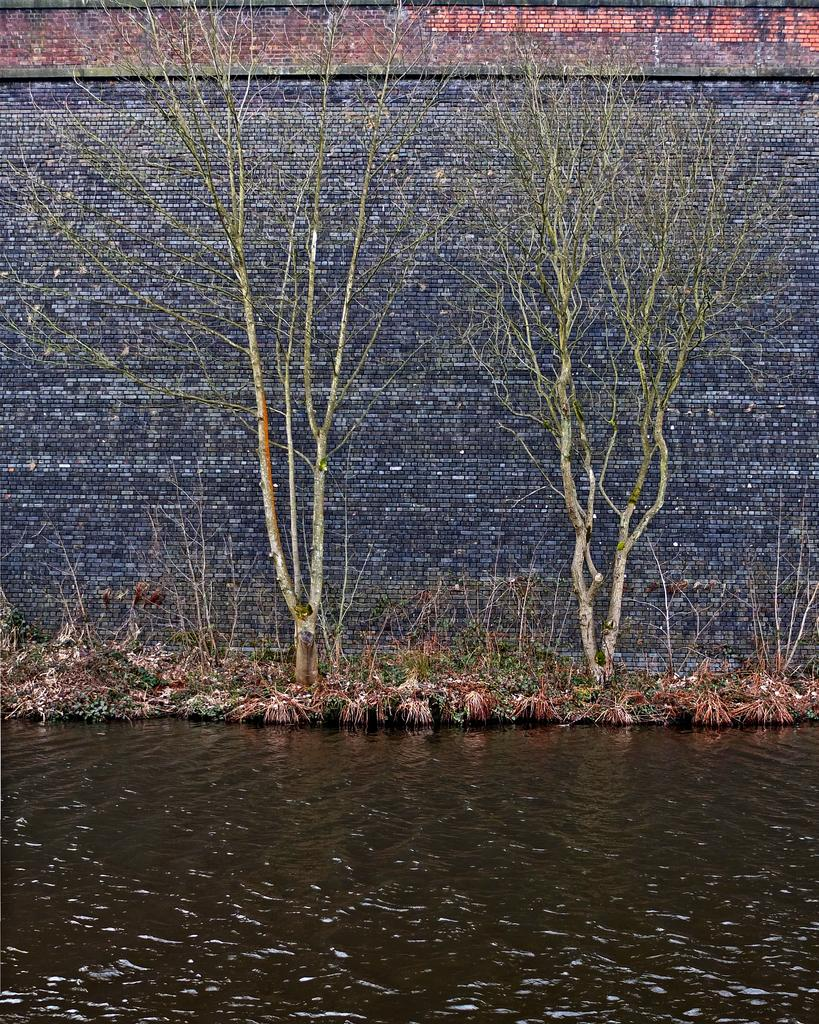What is the primary element in the image? There is water in the image. What type of vegetation can be seen in the image? There is grass and trees visible in the image. What is in the background of the image? There is a wall in the background of the image. What colors are present on the wall? The wall has a grey and brown color. What advice does the mom give during the vacation in the image? There is no mom or vacation present in the image; it features water, grass, trees, and a wall. How does the sailboat navigate through the water in the image? There is no sailboat present in the image; it only features water, grass, trees, and a wall. 